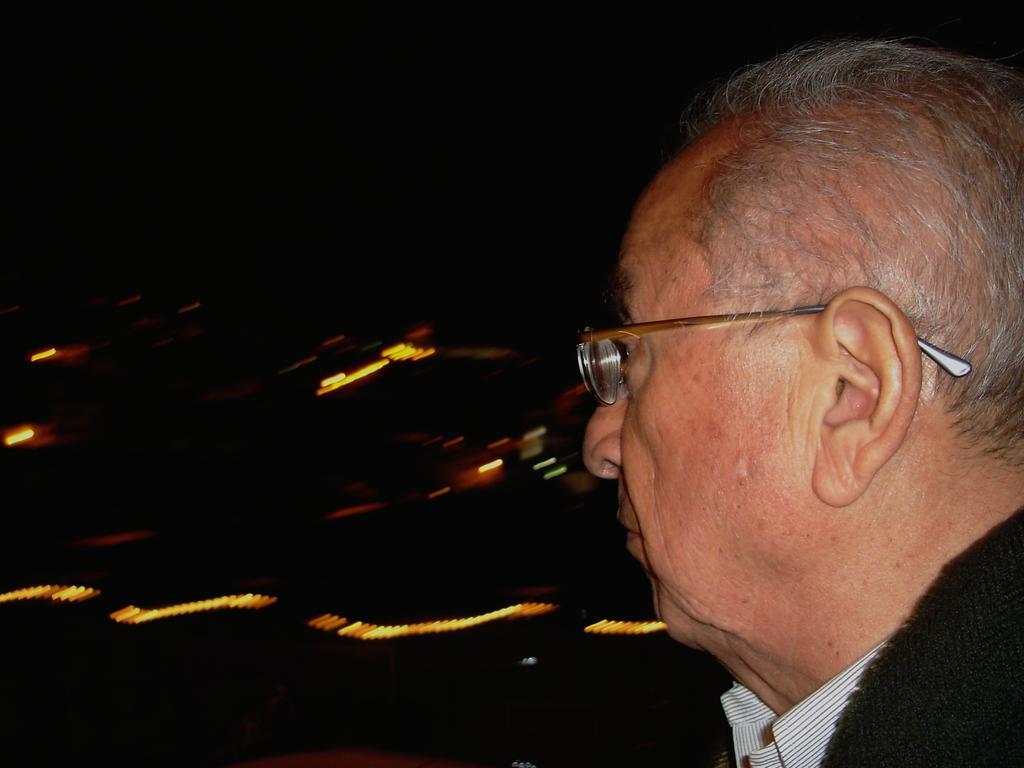In one or two sentences, can you explain what this image depicts? In this image I can see a person ,wearing a spectacle on the right side and on the left side I can see a lighting and dark view. 